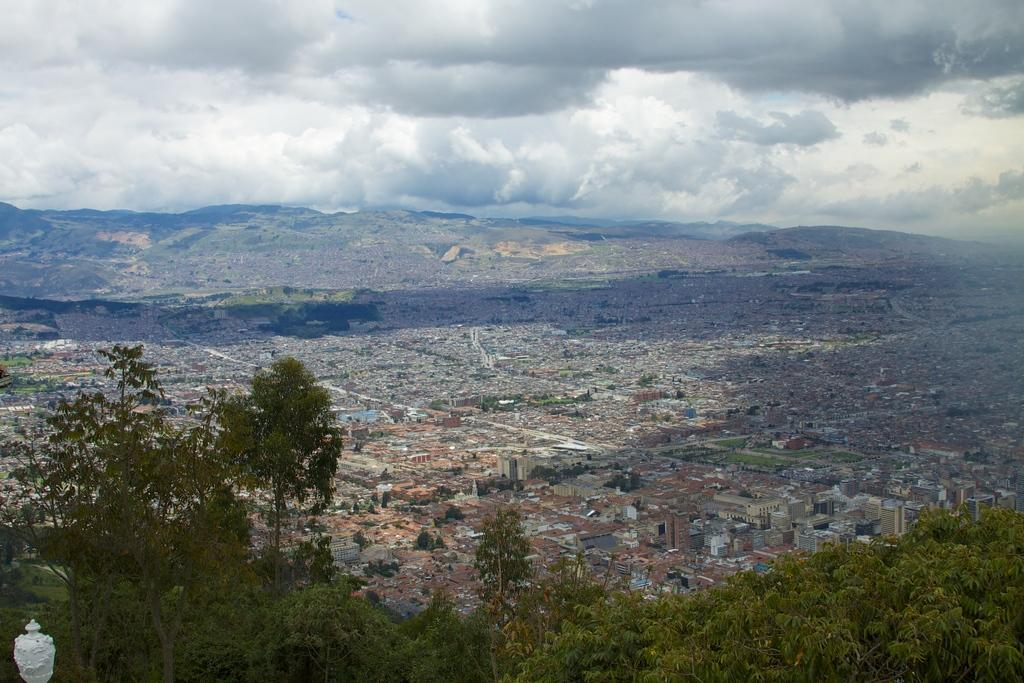What type of structures can be seen in the image? There are buildings in the image. What other natural elements are present in the image? There are trees in the image. What can be seen in the distance in the background of the image? There are mountains and clouds in the background of the image. How many cooks are present at the event in the image? There is no event or cooks present in the image; it features buildings, trees, mountains, and clouds. 